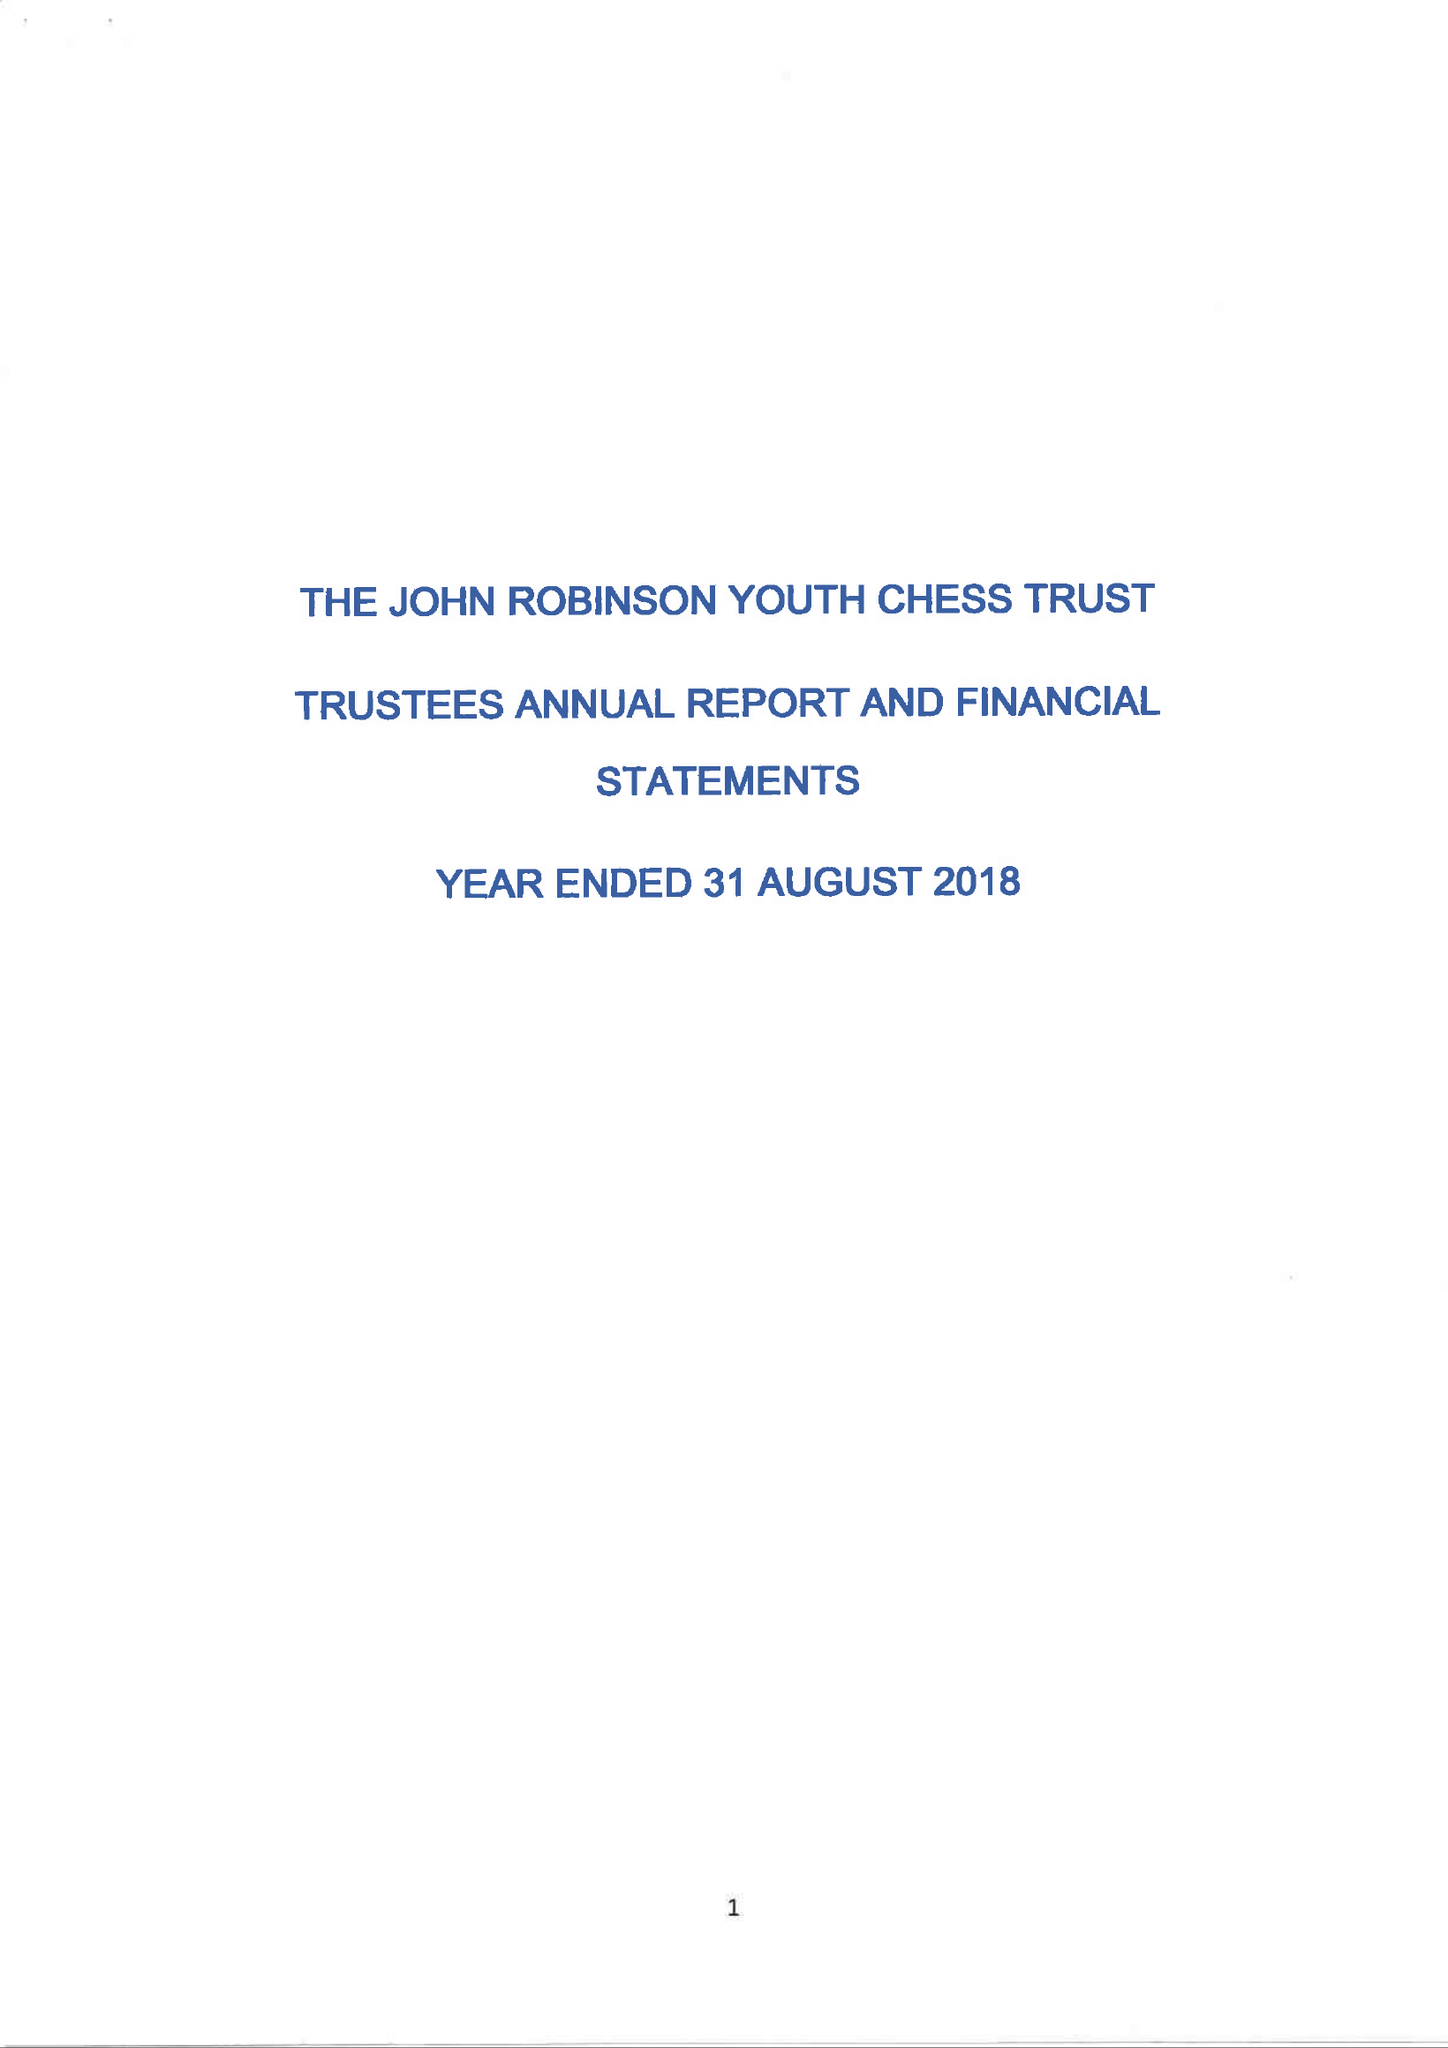What is the value for the address__post_town?
Answer the question using a single word or phrase. CRAWLEY 